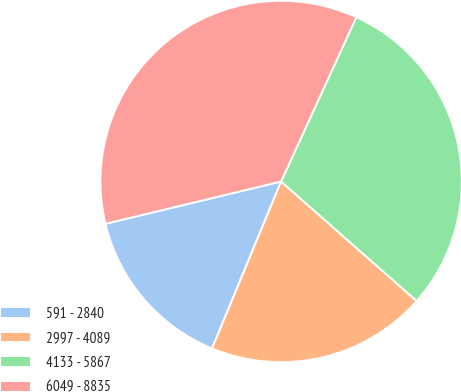Convert chart to OTSL. <chart><loc_0><loc_0><loc_500><loc_500><pie_chart><fcel>591 - 2840<fcel>2997 - 4089<fcel>4133 - 5867<fcel>6049 - 8835<nl><fcel>15.0%<fcel>19.74%<fcel>29.67%<fcel>35.6%<nl></chart> 